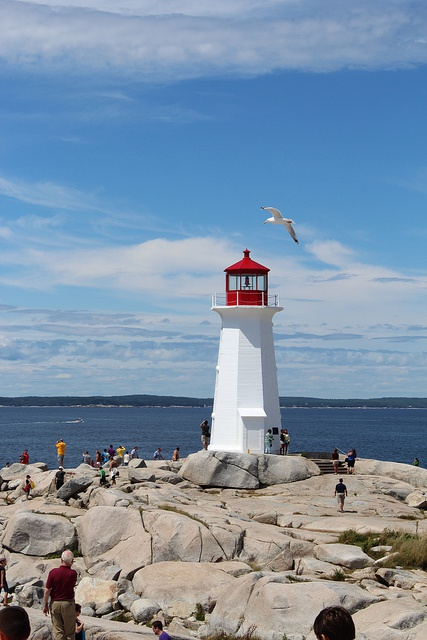Describe the objects in this image and their specific colors. I can see people in darkgray, gray, black, and blue tones, people in darkgray, black, maroon, and gray tones, people in darkgray, black, maroon, and gray tones, bird in darkgray, gray, and lightgray tones, and people in darkgray, black, and gray tones in this image. 